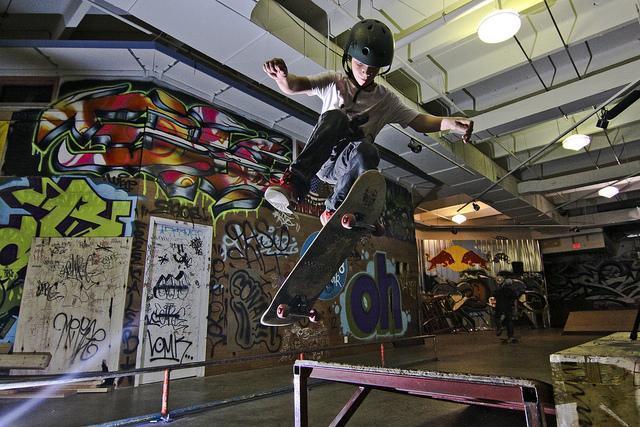How did the skateboarder get so high in the air?
Choose the right answer and clarify with the format: 'Answer: answer
Rationale: rationale.'
Options: Vaulted, ramp, trampoline, spring board. Answer: ramp.
Rationale: The skateboarder used the ramp. 